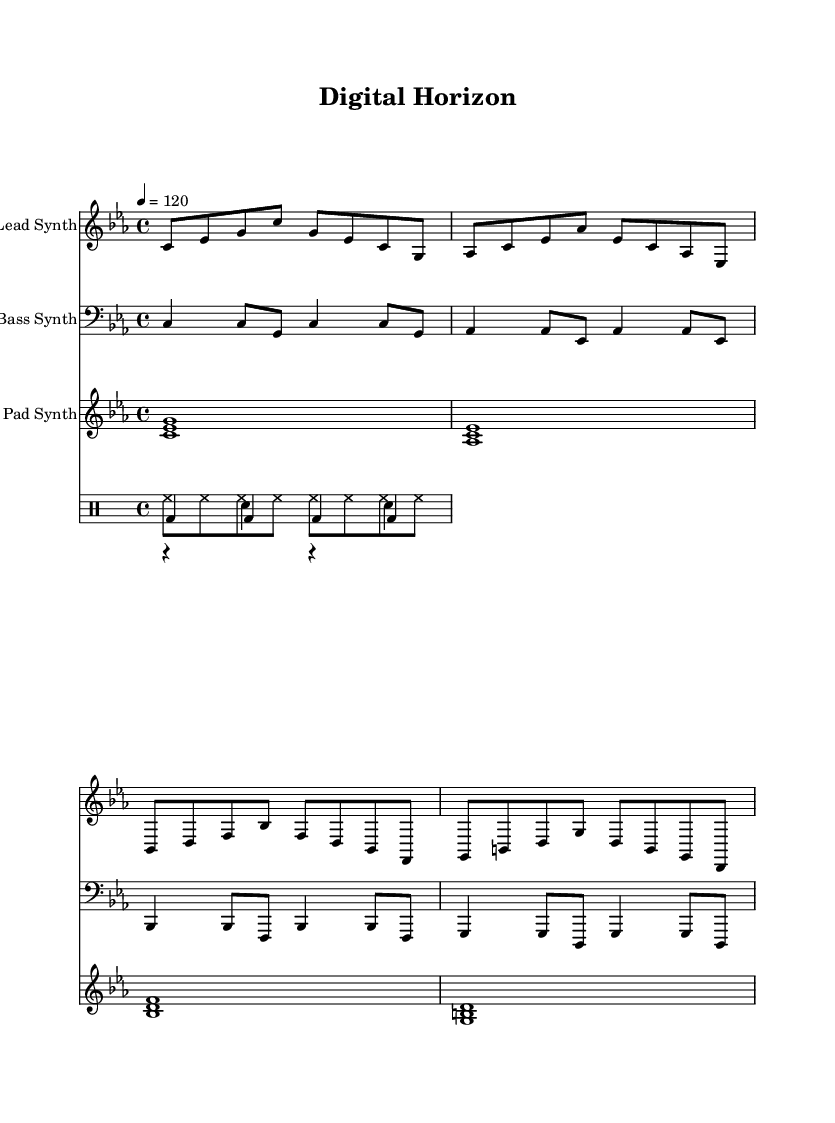what is the key signature of this music? The key signature shown in the global block is C minor, indicated by the presence of three flats (B, E, and A) in the key signature display.
Answer: C minor what is the time signature of this music? The time signature indicated in the global block is in 4/4, meaning there are four beats per measure, and the quarter note gets one beat.
Answer: 4/4 what is the tempo of this music? The tempo is indicated to be 120 beats per minute, meaning there are 120 quarter note beats in one minute of music.
Answer: 120 which instrument plays the lead melody? The lead melody is played by the "Lead Synth," as specified in the staff designation for that part.
Answer: Lead Synth how many measures are in the Lead Synth part? By observing the notation for the Lead Synth, we count 8 measures of music as represented by the segments divided into appropriate bar lines.
Answer: 8 what type of drum pattern is present in the drum section? The drum section includes kick, snare, and hi-hat patterns, indicating a standard electronic drum groove common in Synthwave compositions, with consistent beats typical of this genre.
Answer: Electronic drum groove how does the bass synth contribute to the harmony? The bass synth plays a foundational role by providing root notes and reinforcing the harmonic structure, emphasizing the chord progressions typical in Synthwave music.
Answer: Foundation of harmony 